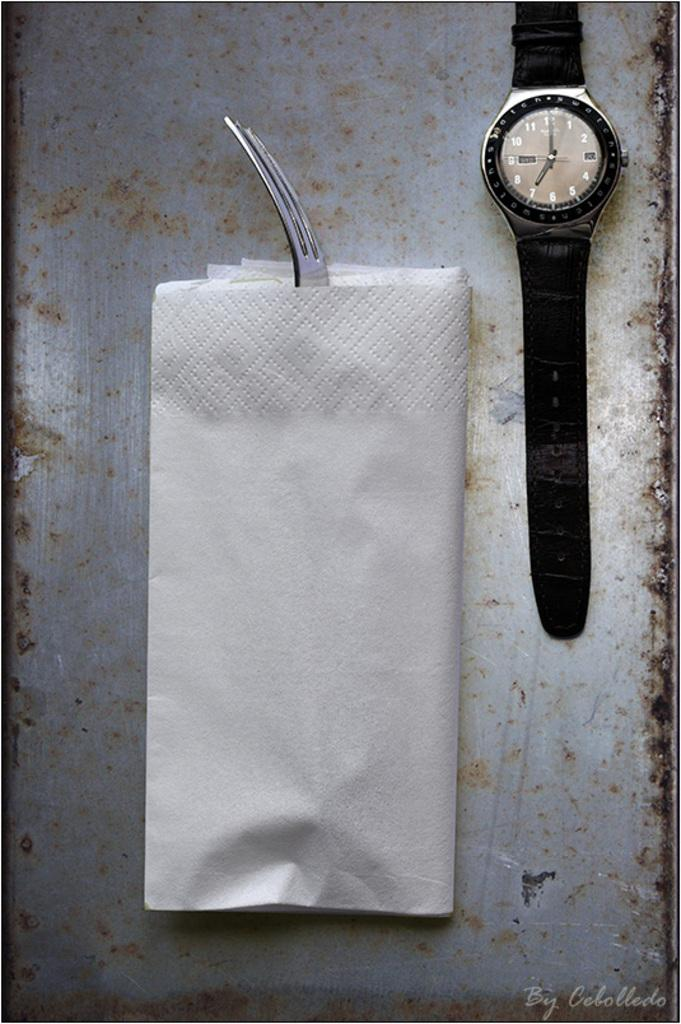<image>
Offer a succinct explanation of the picture presented. a watch with 1 thru 12 on the front 